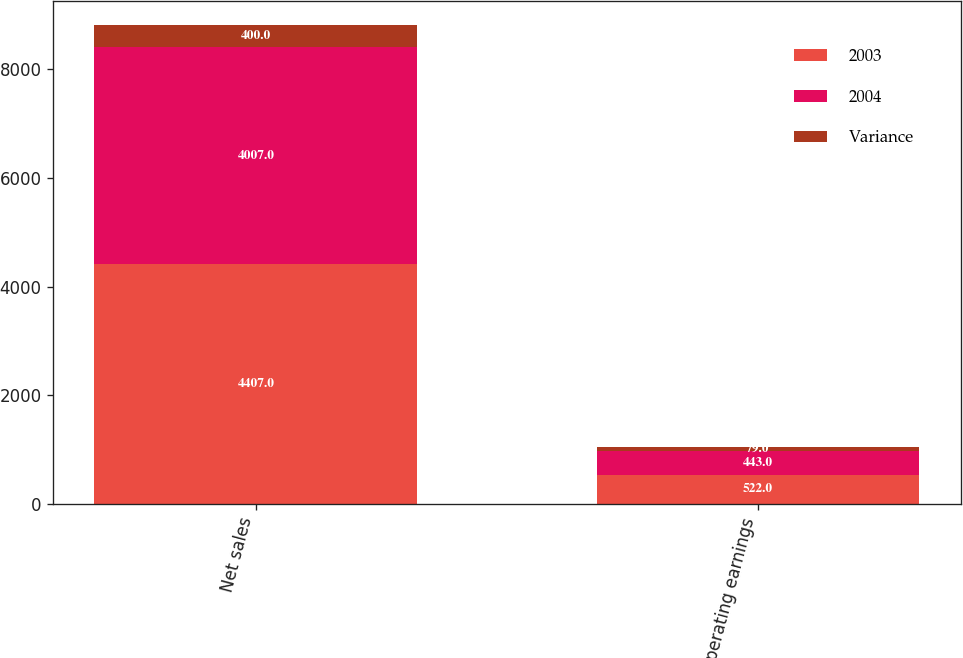<chart> <loc_0><loc_0><loc_500><loc_500><stacked_bar_chart><ecel><fcel>Net sales<fcel>Operating earnings<nl><fcel>2003<fcel>4407<fcel>522<nl><fcel>2004<fcel>4007<fcel>443<nl><fcel>Variance<fcel>400<fcel>79<nl></chart> 